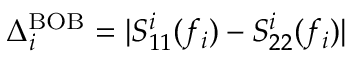Convert formula to latex. <formula><loc_0><loc_0><loc_500><loc_500>\Delta _ { i } ^ { B O B } = | S _ { 1 1 } ^ { i } ( f _ { i } ) - S _ { 2 2 } ^ { i } ( f _ { i } ) |</formula> 